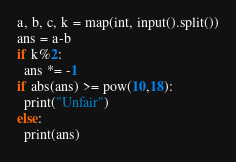<code> <loc_0><loc_0><loc_500><loc_500><_Python_>a, b, c, k = map(int, input().split())
ans = a-b
if k%2:
  ans *= -1
if abs(ans) >= pow(10,18):
  print("Unfair")
else:
  print(ans)</code> 